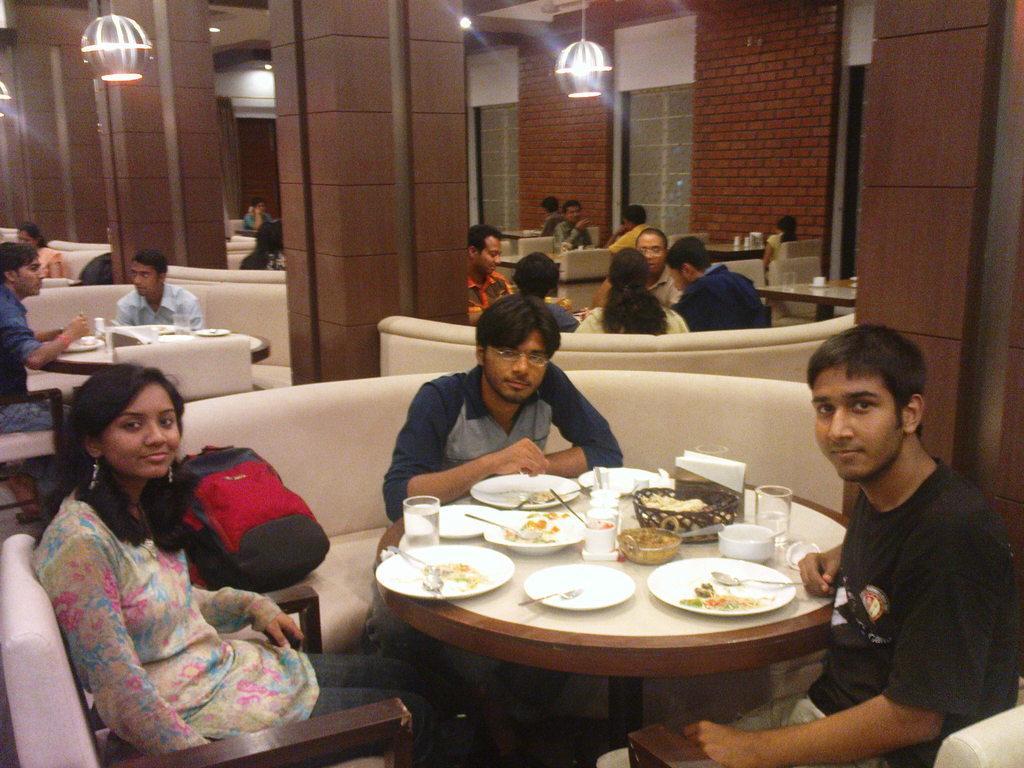Could you give a brief overview of what you see in this image? This picture describes about group of people, they are all seated on the chair and sofa, and they are in the restaurant, in front of them we can see plates, glasses, food on the table, on top of them we can see couple of lights. 